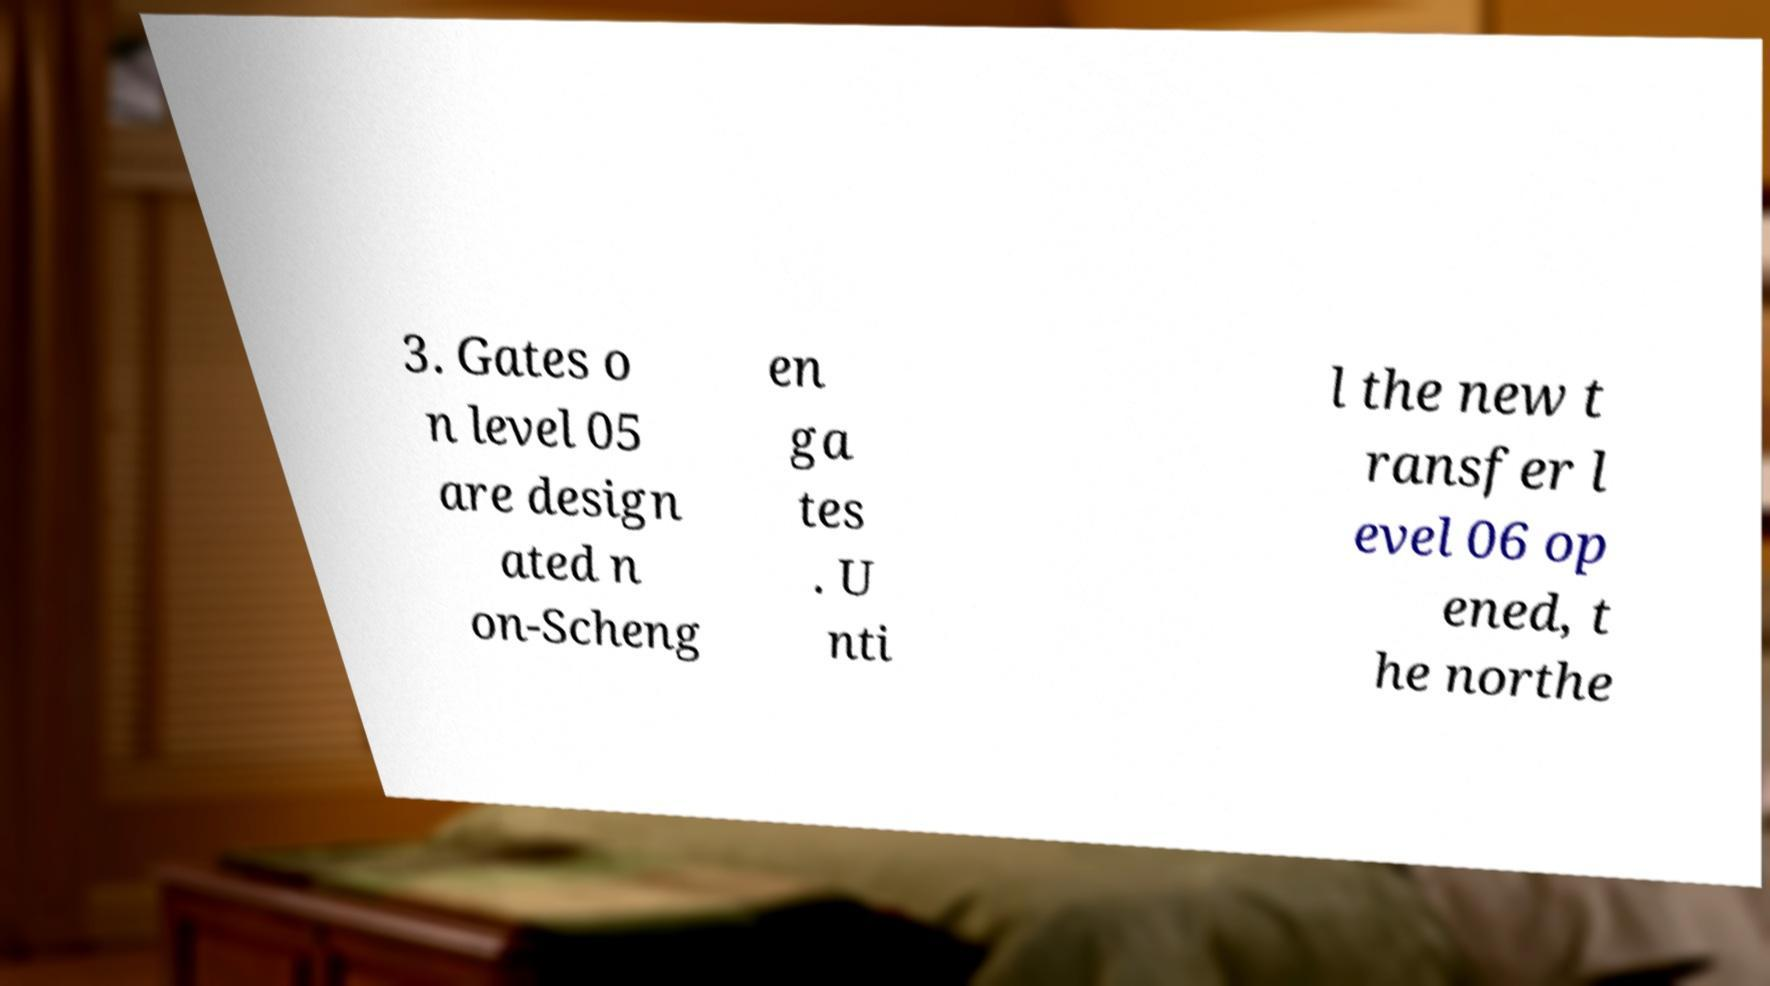Could you assist in decoding the text presented in this image and type it out clearly? 3. Gates o n level 05 are design ated n on-Scheng en ga tes . U nti l the new t ransfer l evel 06 op ened, t he northe 